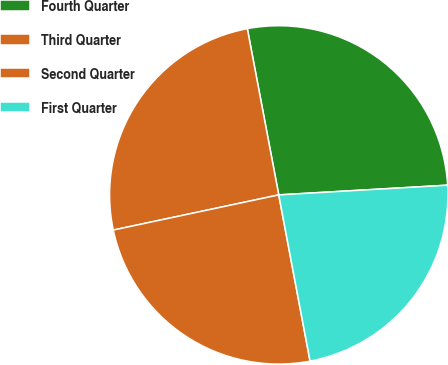Convert chart. <chart><loc_0><loc_0><loc_500><loc_500><pie_chart><fcel>Fourth Quarter<fcel>Third Quarter<fcel>Second Quarter<fcel>First Quarter<nl><fcel>27.06%<fcel>25.36%<fcel>24.63%<fcel>22.95%<nl></chart> 